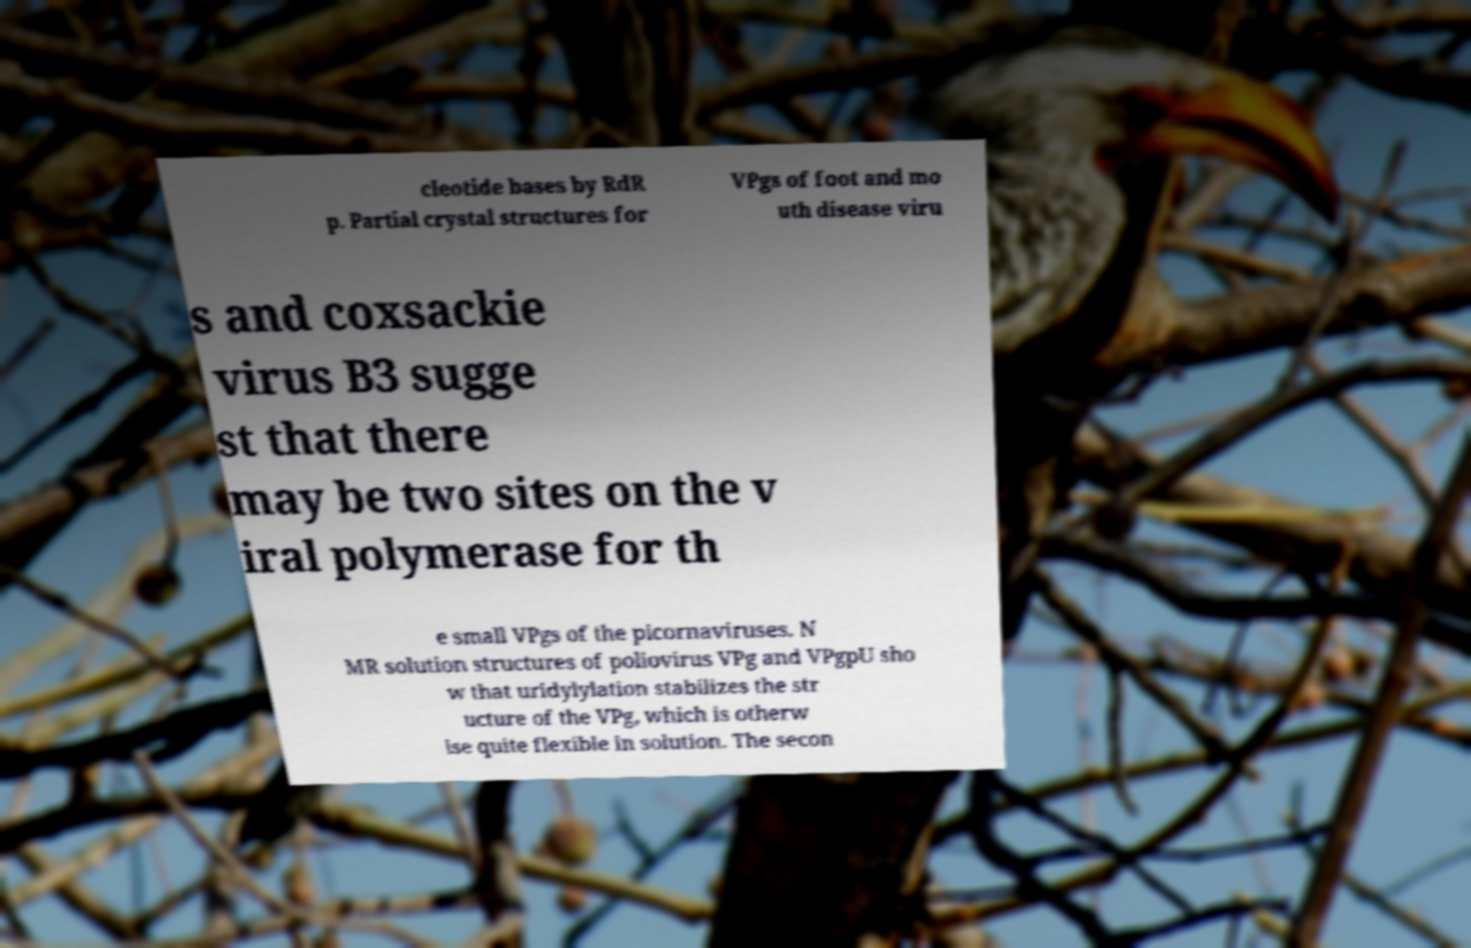Could you assist in decoding the text presented in this image and type it out clearly? cleotide bases by RdR p. Partial crystal structures for VPgs of foot and mo uth disease viru s and coxsackie virus B3 sugge st that there may be two sites on the v iral polymerase for th e small VPgs of the picornaviruses. N MR solution structures of poliovirus VPg and VPgpU sho w that uridylylation stabilizes the str ucture of the VPg, which is otherw ise quite flexible in solution. The secon 